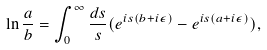Convert formula to latex. <formula><loc_0><loc_0><loc_500><loc_500>\ln \frac { a } { b } = \int ^ { \infty } _ { 0 } \frac { d s } { s } ( e ^ { i s ( b + i \epsilon ) } - e ^ { i s ( a + i \epsilon ) } ) ,</formula> 